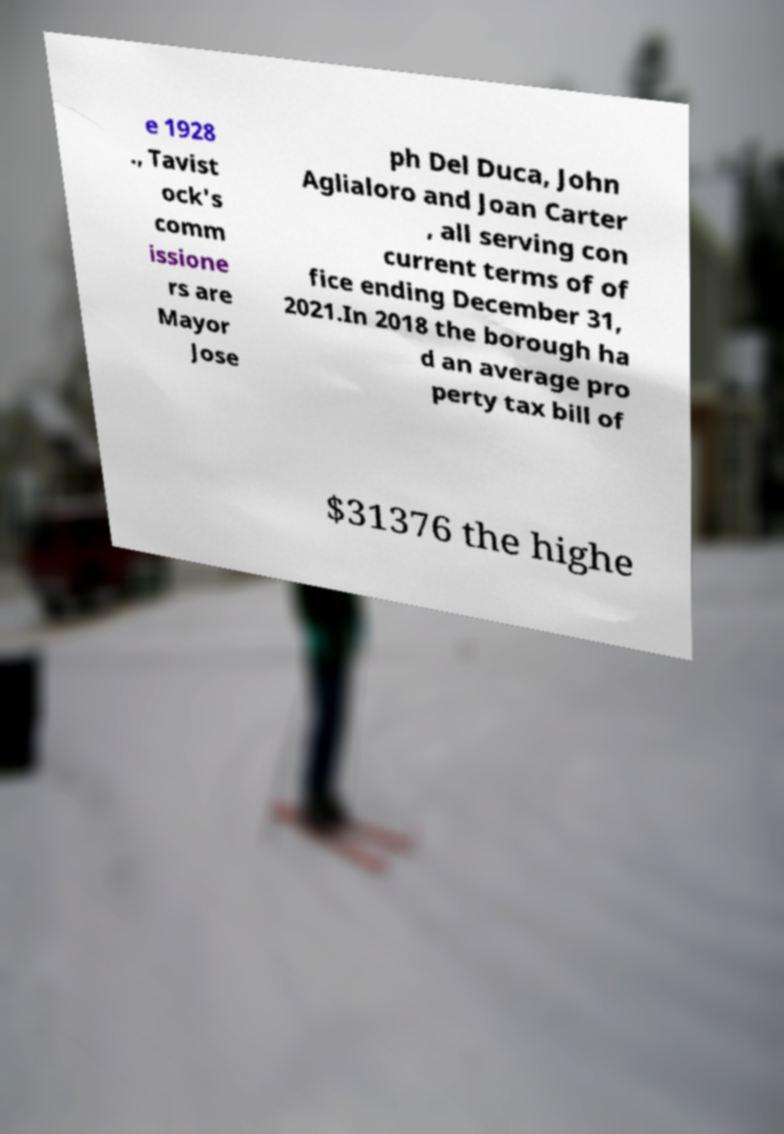Can you accurately transcribe the text from the provided image for me? e 1928 ., Tavist ock's comm issione rs are Mayor Jose ph Del Duca, John Aglialoro and Joan Carter , all serving con current terms of of fice ending December 31, 2021.In 2018 the borough ha d an average pro perty tax bill of $31376 the highe 